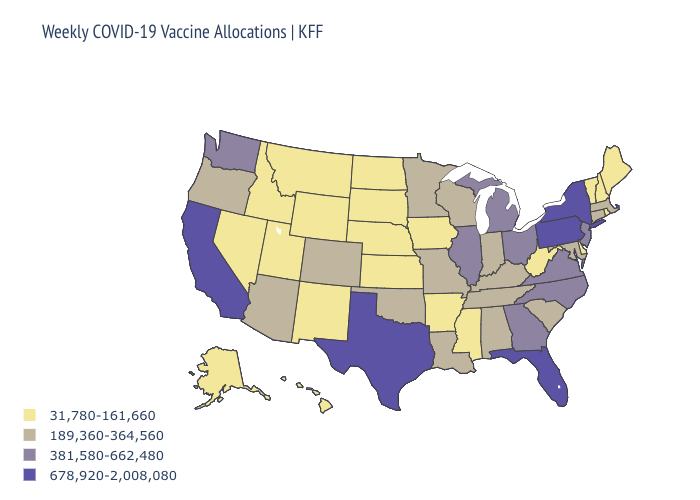What is the value of Mississippi?
Write a very short answer. 31,780-161,660. Name the states that have a value in the range 678,920-2,008,080?
Write a very short answer. California, Florida, New York, Pennsylvania, Texas. What is the highest value in states that border Nebraska?
Write a very short answer. 189,360-364,560. Which states have the lowest value in the South?
Keep it brief. Arkansas, Delaware, Mississippi, West Virginia. What is the value of Illinois?
Keep it brief. 381,580-662,480. What is the value of Kentucky?
Concise answer only. 189,360-364,560. Which states have the lowest value in the MidWest?
Quick response, please. Iowa, Kansas, Nebraska, North Dakota, South Dakota. Which states hav the highest value in the MidWest?
Quick response, please. Illinois, Michigan, Ohio. Name the states that have a value in the range 189,360-364,560?
Give a very brief answer. Alabama, Arizona, Colorado, Connecticut, Indiana, Kentucky, Louisiana, Maryland, Massachusetts, Minnesota, Missouri, Oklahoma, Oregon, South Carolina, Tennessee, Wisconsin. What is the lowest value in the MidWest?
Give a very brief answer. 31,780-161,660. Name the states that have a value in the range 381,580-662,480?
Give a very brief answer. Georgia, Illinois, Michigan, New Jersey, North Carolina, Ohio, Virginia, Washington. Name the states that have a value in the range 189,360-364,560?
Short answer required. Alabama, Arizona, Colorado, Connecticut, Indiana, Kentucky, Louisiana, Maryland, Massachusetts, Minnesota, Missouri, Oklahoma, Oregon, South Carolina, Tennessee, Wisconsin. What is the value of Kentucky?
Short answer required. 189,360-364,560. Does the first symbol in the legend represent the smallest category?
Be succinct. Yes. 